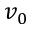Convert formula to latex. <formula><loc_0><loc_0><loc_500><loc_500>v _ { 0 }</formula> 